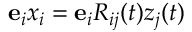<formula> <loc_0><loc_0><loc_500><loc_500>{ e } _ { i } x _ { i } = { e } _ { i } R _ { i j } ( t ) z _ { j } ( t )</formula> 